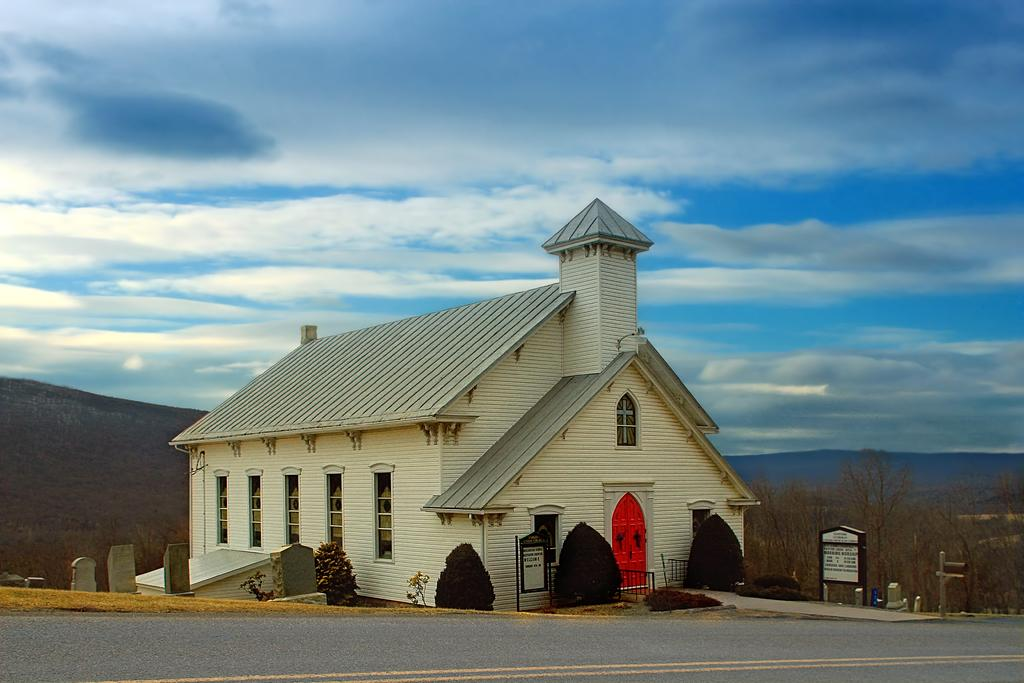What type of structure is visible in the image? There is a house in the image. What feature of the house is mentioned in the facts? The house has windows. What other objects or elements can be seen in the image? There are plants, a board, mountains, and the sky visible in the image. What type of engine is used to power the house in the image? There is no engine mentioned or visible in the image; it is a house with windows and other elements. How much money is in the account associated with the house in the image? There is no mention of an account or any financial information related to the house in the image. 